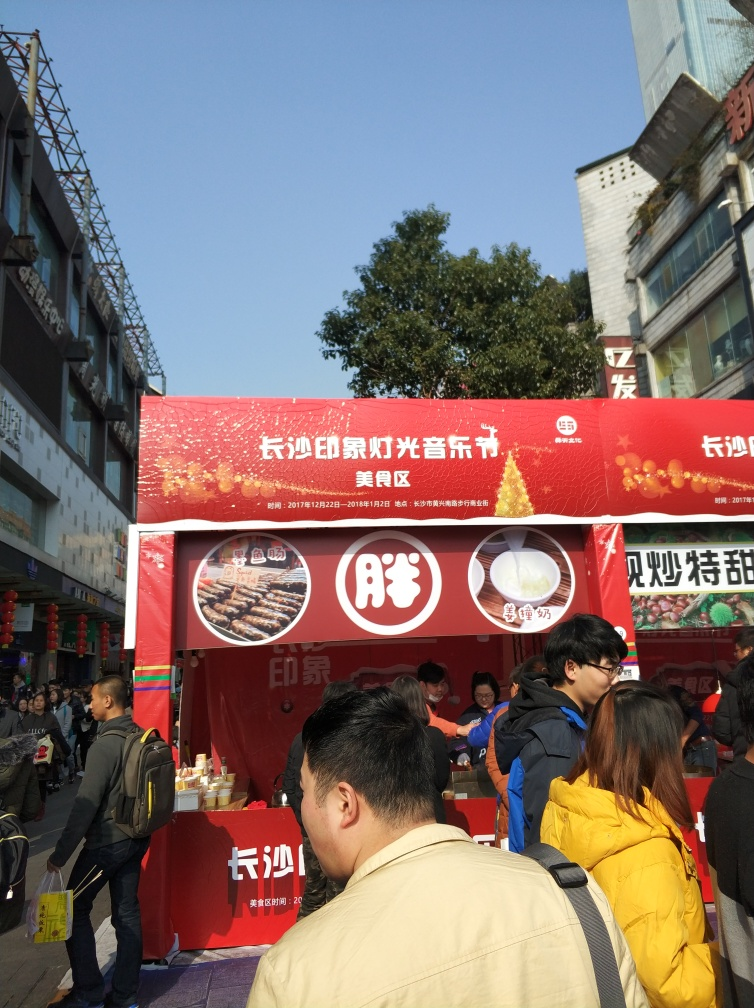Is the overall clarity of the image high?
 Yes 